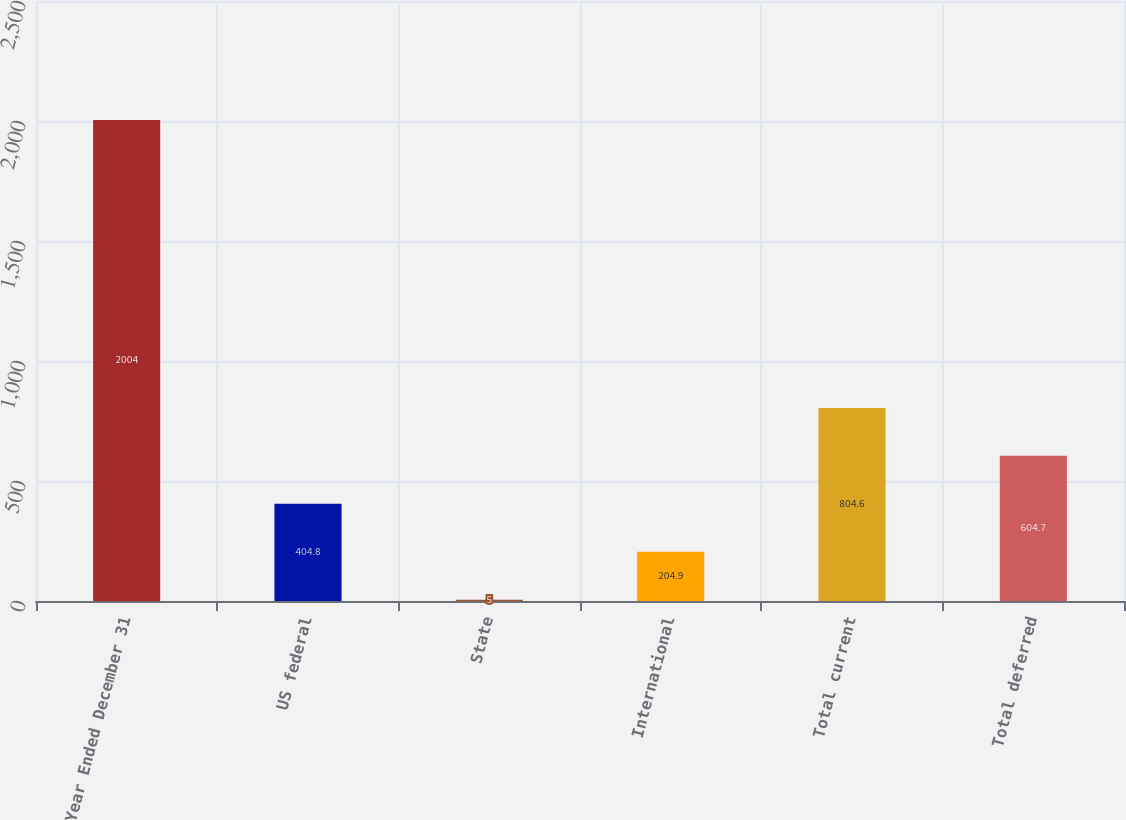Convert chart to OTSL. <chart><loc_0><loc_0><loc_500><loc_500><bar_chart><fcel>Year Ended December 31<fcel>US federal<fcel>State<fcel>International<fcel>Total current<fcel>Total deferred<nl><fcel>2004<fcel>404.8<fcel>5<fcel>204.9<fcel>804.6<fcel>604.7<nl></chart> 